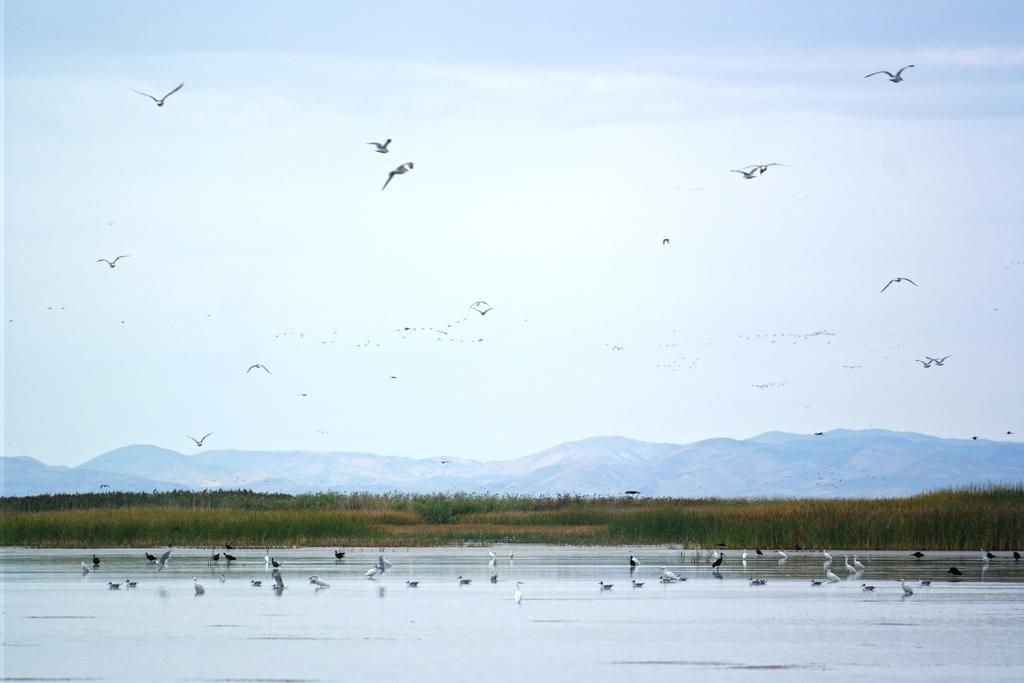What type of animals can be seen in the image? Birds can be seen in the image. What is the primary element in which the birds are situated? The birds are situated in water. Can you describe the birds' actions in the image? Some birds are flying in the air. What can be seen in the background of the image? There is grass, hills, and the sky visible in the background of the image. What type of fork can be seen in the hands of the fireman in the image? There is no fireman or fork present in the image; it features birds in water with a grassy and hilly background. 